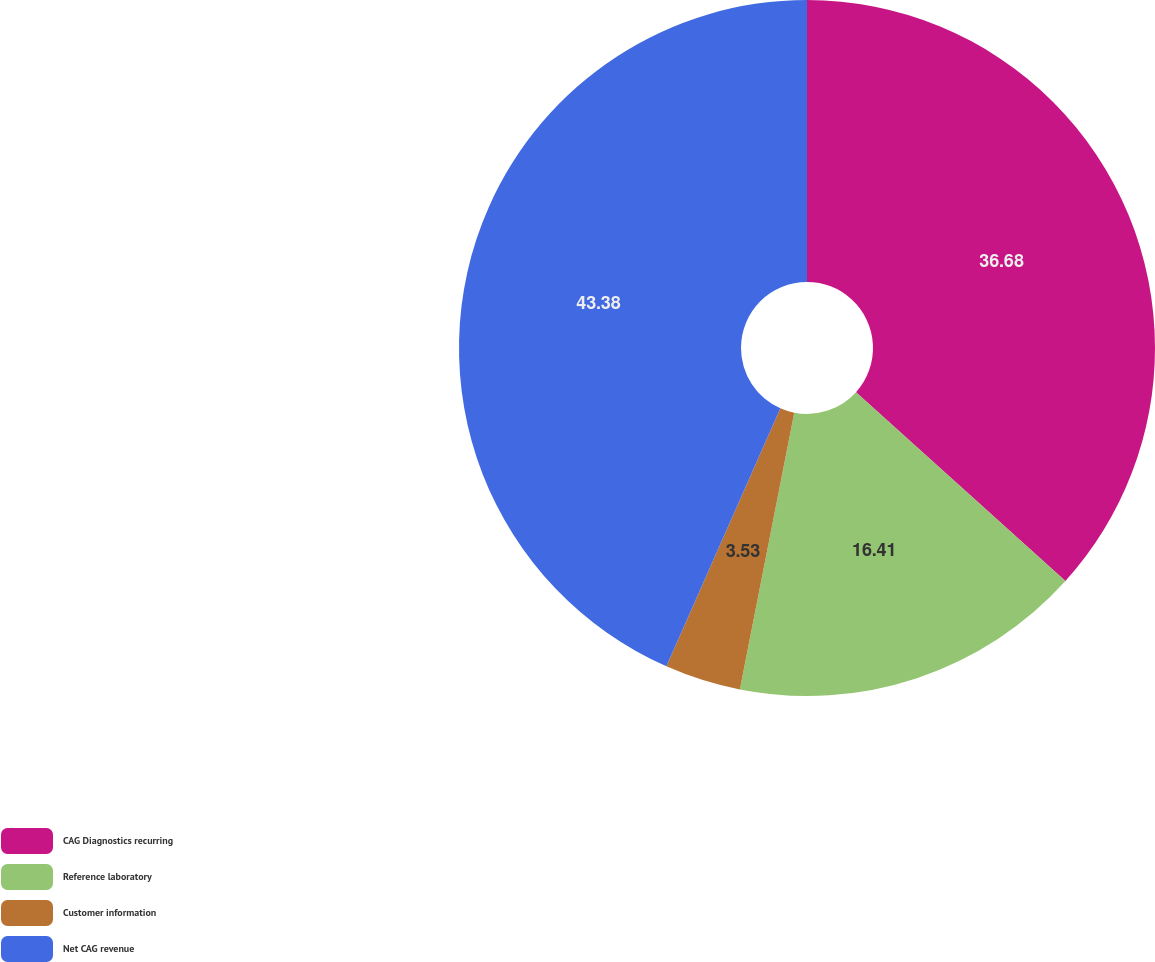Convert chart to OTSL. <chart><loc_0><loc_0><loc_500><loc_500><pie_chart><fcel>CAG Diagnostics recurring<fcel>Reference laboratory<fcel>Customer information<fcel>Net CAG revenue<nl><fcel>36.68%<fcel>16.41%<fcel>3.53%<fcel>43.38%<nl></chart> 